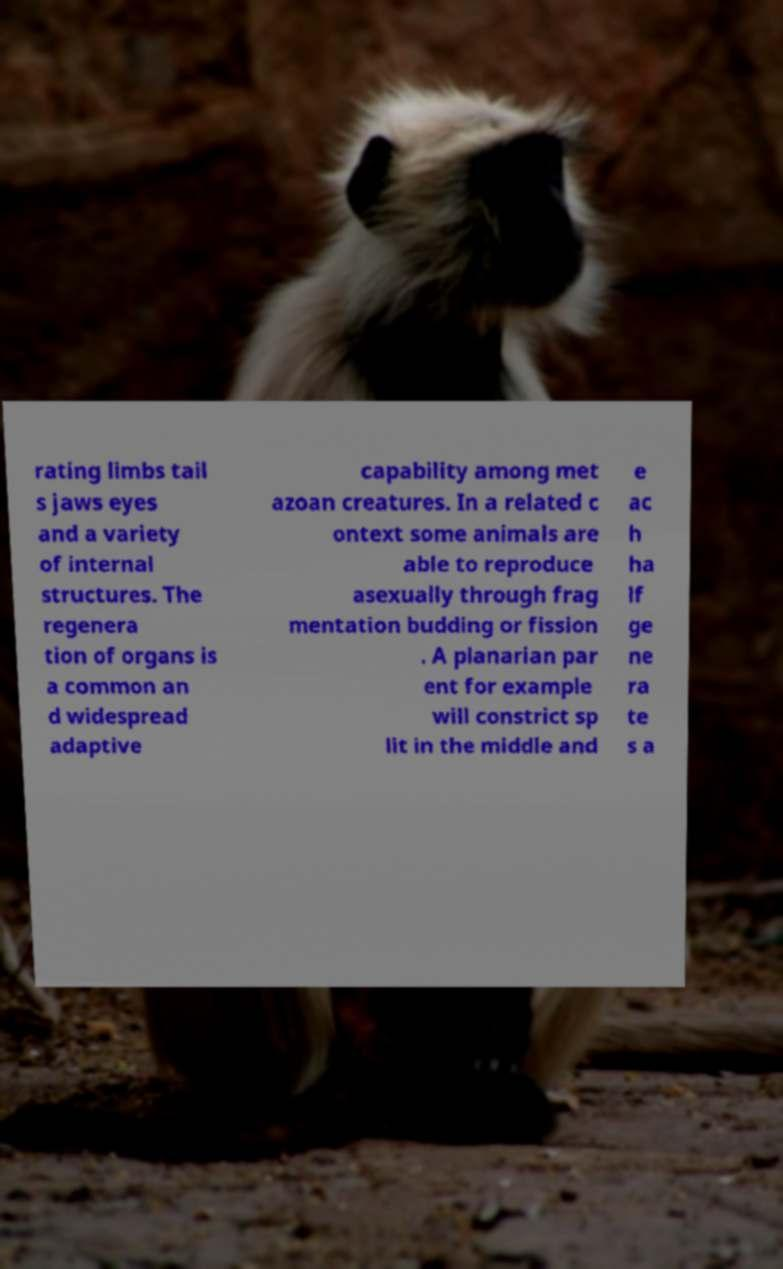What messages or text are displayed in this image? I need them in a readable, typed format. rating limbs tail s jaws eyes and a variety of internal structures. The regenera tion of organs is a common an d widespread adaptive capability among met azoan creatures. In a related c ontext some animals are able to reproduce asexually through frag mentation budding or fission . A planarian par ent for example will constrict sp lit in the middle and e ac h ha lf ge ne ra te s a 